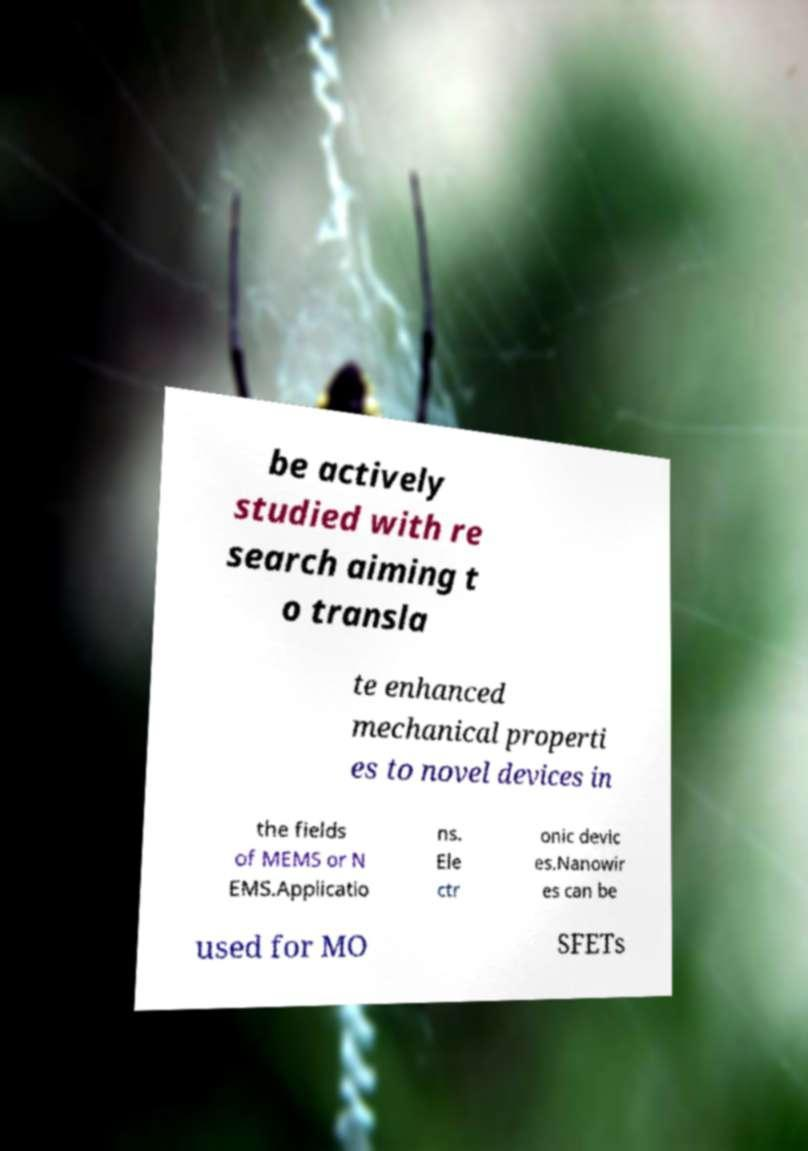Can you accurately transcribe the text from the provided image for me? be actively studied with re search aiming t o transla te enhanced mechanical properti es to novel devices in the fields of MEMS or N EMS.Applicatio ns. Ele ctr onic devic es.Nanowir es can be used for MO SFETs 